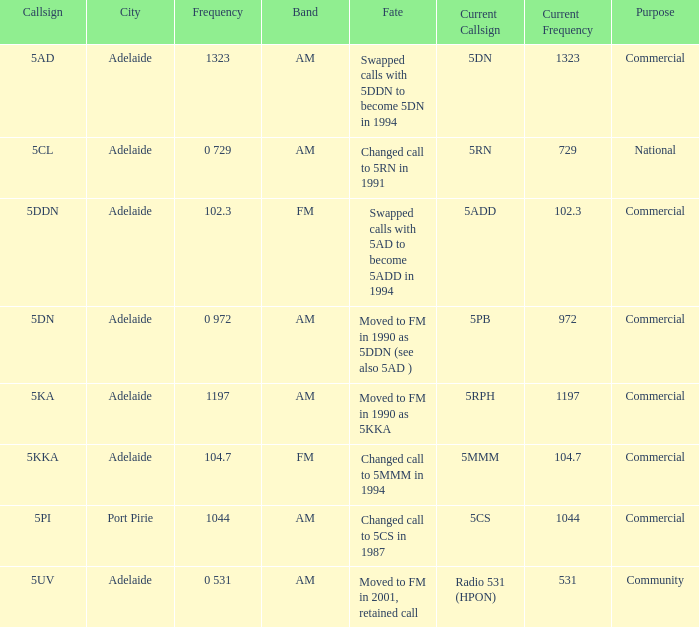What is the current freq for Frequency of 104.7? 5MMM. Help me parse the entirety of this table. {'header': ['Callsign', 'City', 'Frequency', 'Band', 'Fate', 'Current Callsign', 'Current Frequency', 'Purpose'], 'rows': [['5AD', 'Adelaide', '1323', 'AM', 'Swapped calls with 5DDN to become 5DN in 1994', '5DN', '1323', 'Commercial'], ['5CL', 'Adelaide', '0 729', 'AM', 'Changed call to 5RN in 1991', '5RN', '729', 'National'], ['5DDN', 'Adelaide', '102.3', 'FM', 'Swapped calls with 5AD to become 5ADD in 1994', '5ADD', '102.3', 'Commercial'], ['5DN', 'Adelaide', '0 972', 'AM', 'Moved to FM in 1990 as 5DDN (see also 5AD )', '5PB', '972', 'Commercial'], ['5KA', 'Adelaide', '1197', 'AM', 'Moved to FM in 1990 as 5KKA', '5RPH', '1197', 'Commercial'], ['5KKA', 'Adelaide', '104.7', 'FM', 'Changed call to 5MMM in 1994', '5MMM', '104.7', 'Commercial'], ['5PI', 'Port Pirie', '1044', 'AM', 'Changed call to 5CS in 1987', '5CS', '1044', 'Commercial'], ['5UV', 'Adelaide', '0 531', 'AM', 'Moved to FM in 2001, retained call', 'Radio 531 (HPON)', '531', 'Community']]} 